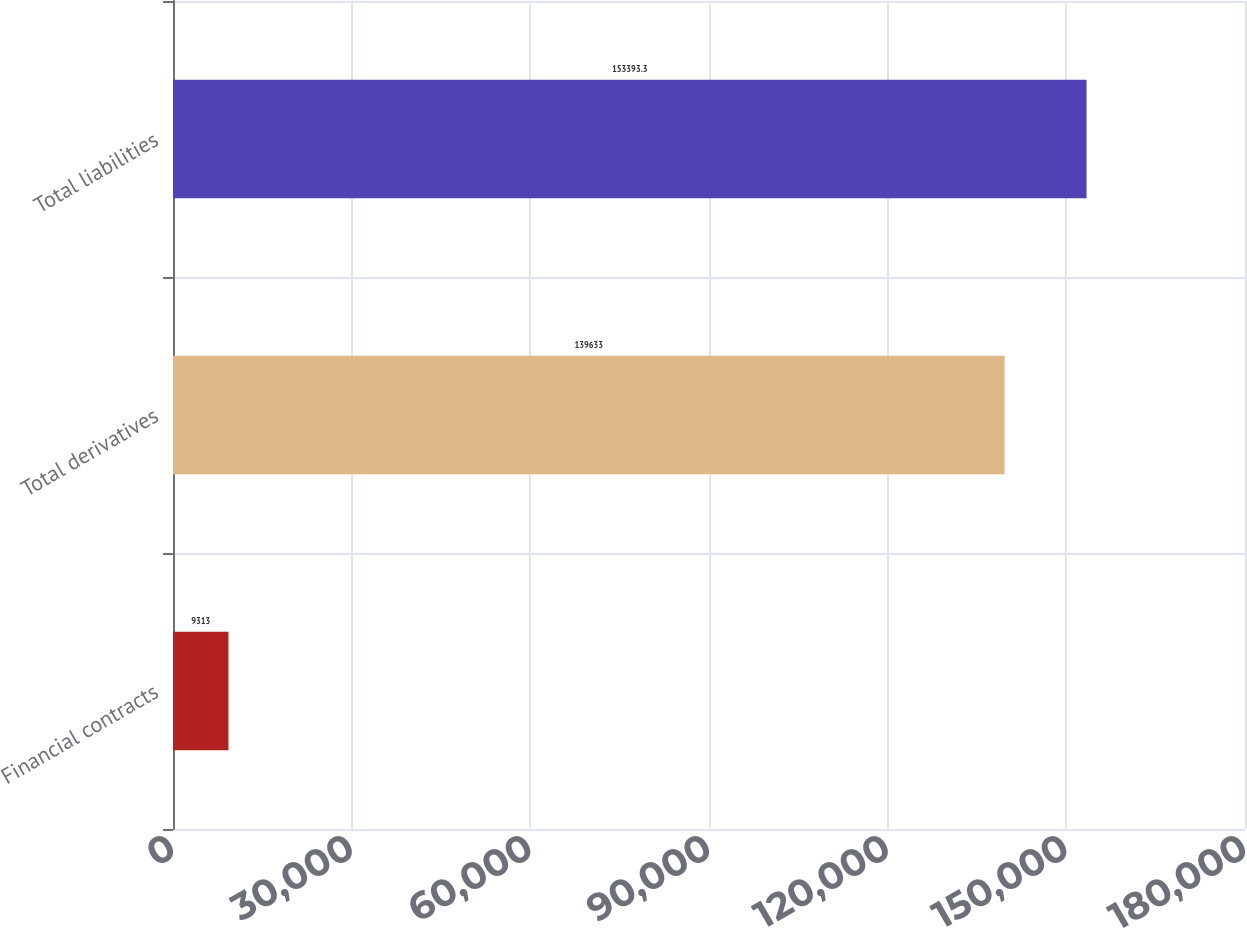<chart> <loc_0><loc_0><loc_500><loc_500><bar_chart><fcel>Financial contracts<fcel>Total derivatives<fcel>Total liabilities<nl><fcel>9313<fcel>139633<fcel>153393<nl></chart> 